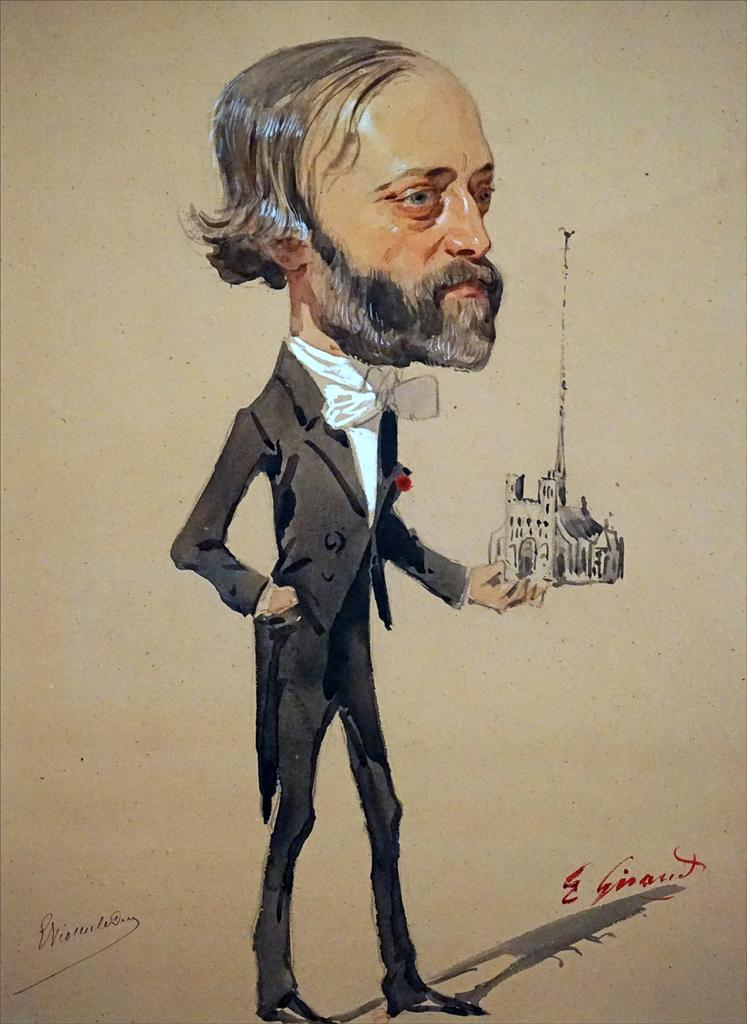What type of artwork is depicted in the image? The image is a painting. Can you describe the main subject of the painting? There is a man in the center of the painting. What other elements can be seen in the painting? There is a building on the right side of the painting. Is there any text present in the painting? Yes, there is text present in the painting. What type of mountain can be seen in the background of the painting? There is no mountain present in the painting; it features a man, a building, and text. Can you describe the form of the wall in the painting? There is no wall present in the painting; it features a man, a building, and text. 